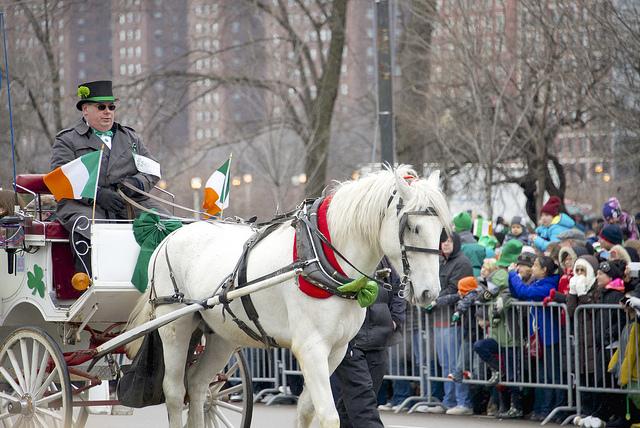What holiday celebration is this a photo of?
Short answer required. St patrick's day. How many horses are pictured?
Be succinct. 1. How many horses are there?
Quick response, please. 1. What color is the horse?
Write a very short answer. White. Are these palace guards?
Give a very brief answer. No. 